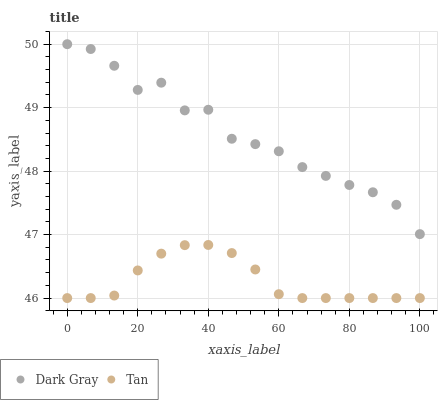Does Tan have the minimum area under the curve?
Answer yes or no. Yes. Does Dark Gray have the maximum area under the curve?
Answer yes or no. Yes. Does Tan have the maximum area under the curve?
Answer yes or no. No. Is Tan the smoothest?
Answer yes or no. Yes. Is Dark Gray the roughest?
Answer yes or no. Yes. Is Tan the roughest?
Answer yes or no. No. Does Tan have the lowest value?
Answer yes or no. Yes. Does Dark Gray have the highest value?
Answer yes or no. Yes. Does Tan have the highest value?
Answer yes or no. No. Is Tan less than Dark Gray?
Answer yes or no. Yes. Is Dark Gray greater than Tan?
Answer yes or no. Yes. Does Tan intersect Dark Gray?
Answer yes or no. No. 